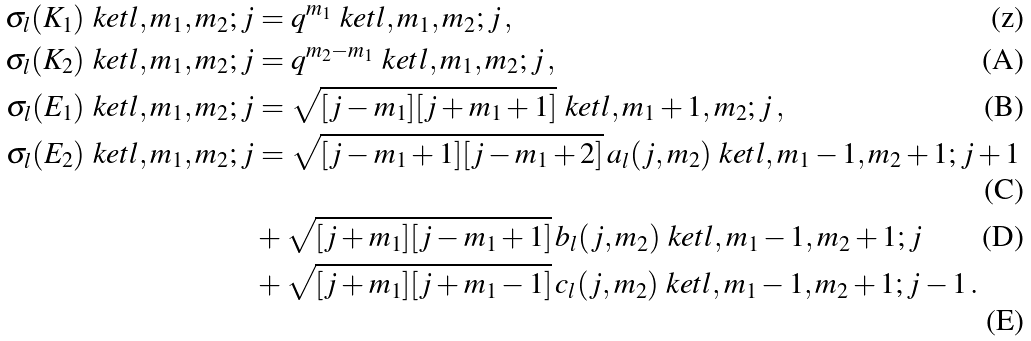<formula> <loc_0><loc_0><loc_500><loc_500>\sigma _ { l } ( K _ { 1 } ) \ k e t { l , m _ { 1 } , m _ { 2 } ; j } & = q ^ { m _ { 1 } } \ k e t { l , m _ { 1 } , m _ { 2 } ; j } \, , \\ \sigma _ { l } ( K _ { 2 } ) \ k e t { l , m _ { 1 } , m _ { 2 } ; j } & = q ^ { m _ { 2 } - m _ { 1 } } \ k e t { l , m _ { 1 } , m _ { 2 } ; j } \, , \\ \sigma _ { l } ( E _ { 1 } ) \ k e t { l , m _ { 1 } , m _ { 2 } ; j } & = \sqrt { [ j - m _ { 1 } ] [ j + m _ { 1 } + 1 ] } \ k e t { l , m _ { 1 } + 1 , m _ { 2 } ; j } \, , \\ \sigma _ { l } ( E _ { 2 } ) \ k e t { l , m _ { 1 } , m _ { 2 } ; j } & = \sqrt { [ j - m _ { 1 } + 1 ] [ j - m _ { 1 } + 2 ] } \, a _ { l } ( j , m _ { 2 } ) \ k e t { l , m _ { 1 } - 1 , m _ { 2 } + 1 ; j + 1 } \\ & + \sqrt { [ j + m _ { 1 } ] [ j - m _ { 1 } + 1 ] } \, b _ { l } ( j , m _ { 2 } ) \ k e t { l , m _ { 1 } - 1 , m _ { 2 } + 1 ; j } \\ & + \sqrt { [ j + m _ { 1 } ] [ j + m _ { 1 } - 1 ] } \, c _ { l } ( j , m _ { 2 } ) \ k e t { l , m _ { 1 } - 1 , m _ { 2 } + 1 ; j - 1 } \, .</formula> 